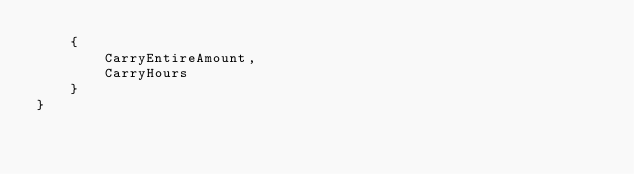Convert code to text. <code><loc_0><loc_0><loc_500><loc_500><_C#_>    {
        CarryEntireAmount,
        CarryHours
    }
}
</code> 